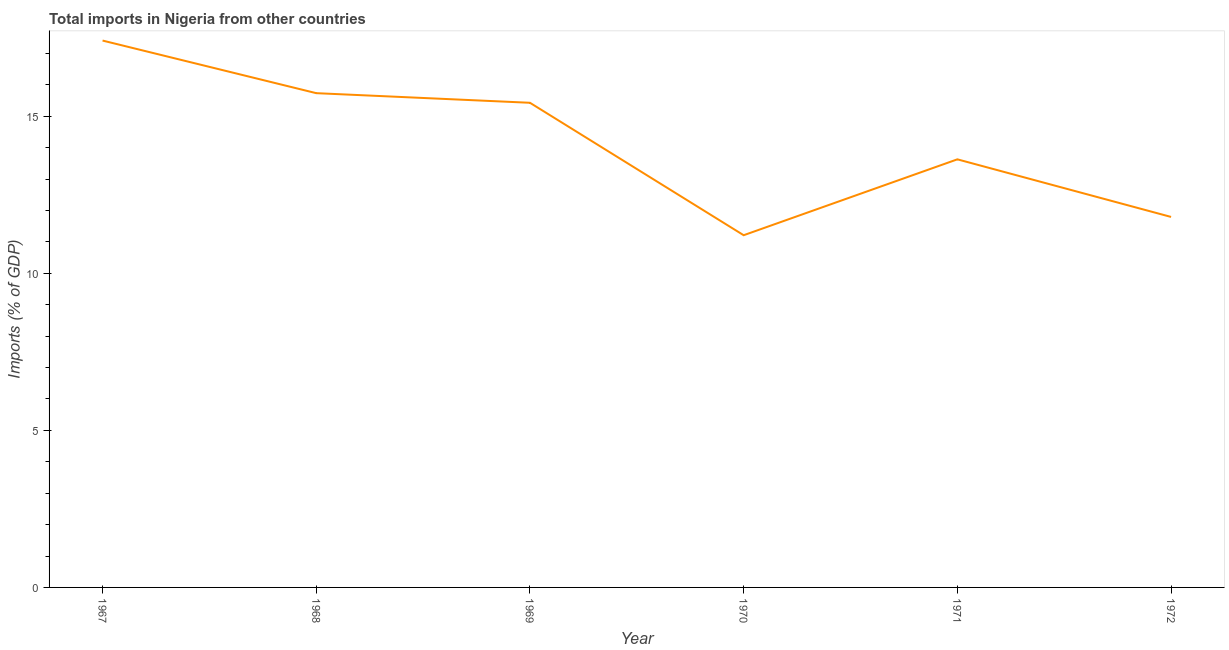What is the total imports in 1971?
Make the answer very short. 13.63. Across all years, what is the maximum total imports?
Offer a terse response. 17.41. Across all years, what is the minimum total imports?
Provide a short and direct response. 11.21. In which year was the total imports maximum?
Offer a very short reply. 1967. In which year was the total imports minimum?
Make the answer very short. 1970. What is the sum of the total imports?
Offer a terse response. 85.22. What is the difference between the total imports in 1969 and 1972?
Offer a very short reply. 3.63. What is the average total imports per year?
Offer a very short reply. 14.2. What is the median total imports?
Ensure brevity in your answer.  14.53. In how many years, is the total imports greater than 4 %?
Ensure brevity in your answer.  6. What is the ratio of the total imports in 1969 to that in 1971?
Provide a short and direct response. 1.13. Is the total imports in 1968 less than that in 1972?
Your response must be concise. No. Is the difference between the total imports in 1970 and 1972 greater than the difference between any two years?
Ensure brevity in your answer.  No. What is the difference between the highest and the second highest total imports?
Offer a very short reply. 1.67. Is the sum of the total imports in 1968 and 1969 greater than the maximum total imports across all years?
Offer a terse response. Yes. What is the difference between the highest and the lowest total imports?
Provide a short and direct response. 6.2. Does the total imports monotonically increase over the years?
Your answer should be compact. No. How many lines are there?
Provide a short and direct response. 1. Does the graph contain any zero values?
Make the answer very short. No. Does the graph contain grids?
Ensure brevity in your answer.  No. What is the title of the graph?
Your response must be concise. Total imports in Nigeria from other countries. What is the label or title of the X-axis?
Make the answer very short. Year. What is the label or title of the Y-axis?
Make the answer very short. Imports (% of GDP). What is the Imports (% of GDP) of 1967?
Your answer should be very brief. 17.41. What is the Imports (% of GDP) of 1968?
Provide a short and direct response. 15.74. What is the Imports (% of GDP) of 1969?
Give a very brief answer. 15.43. What is the Imports (% of GDP) of 1970?
Give a very brief answer. 11.21. What is the Imports (% of GDP) of 1971?
Your answer should be compact. 13.63. What is the Imports (% of GDP) of 1972?
Keep it short and to the point. 11.8. What is the difference between the Imports (% of GDP) in 1967 and 1968?
Make the answer very short. 1.67. What is the difference between the Imports (% of GDP) in 1967 and 1969?
Your response must be concise. 1.98. What is the difference between the Imports (% of GDP) in 1967 and 1970?
Provide a succinct answer. 6.2. What is the difference between the Imports (% of GDP) in 1967 and 1971?
Give a very brief answer. 3.78. What is the difference between the Imports (% of GDP) in 1967 and 1972?
Ensure brevity in your answer.  5.62. What is the difference between the Imports (% of GDP) in 1968 and 1969?
Provide a short and direct response. 0.31. What is the difference between the Imports (% of GDP) in 1968 and 1970?
Make the answer very short. 4.52. What is the difference between the Imports (% of GDP) in 1968 and 1971?
Ensure brevity in your answer.  2.11. What is the difference between the Imports (% of GDP) in 1968 and 1972?
Ensure brevity in your answer.  3.94. What is the difference between the Imports (% of GDP) in 1969 and 1970?
Your response must be concise. 4.22. What is the difference between the Imports (% of GDP) in 1969 and 1971?
Provide a short and direct response. 1.8. What is the difference between the Imports (% of GDP) in 1969 and 1972?
Offer a terse response. 3.63. What is the difference between the Imports (% of GDP) in 1970 and 1971?
Offer a very short reply. -2.42. What is the difference between the Imports (% of GDP) in 1970 and 1972?
Your answer should be compact. -0.58. What is the difference between the Imports (% of GDP) in 1971 and 1972?
Provide a succinct answer. 1.83. What is the ratio of the Imports (% of GDP) in 1967 to that in 1968?
Give a very brief answer. 1.11. What is the ratio of the Imports (% of GDP) in 1967 to that in 1969?
Your response must be concise. 1.13. What is the ratio of the Imports (% of GDP) in 1967 to that in 1970?
Your answer should be compact. 1.55. What is the ratio of the Imports (% of GDP) in 1967 to that in 1971?
Keep it short and to the point. 1.28. What is the ratio of the Imports (% of GDP) in 1967 to that in 1972?
Offer a very short reply. 1.48. What is the ratio of the Imports (% of GDP) in 1968 to that in 1970?
Your answer should be very brief. 1.4. What is the ratio of the Imports (% of GDP) in 1968 to that in 1971?
Make the answer very short. 1.16. What is the ratio of the Imports (% of GDP) in 1968 to that in 1972?
Keep it short and to the point. 1.33. What is the ratio of the Imports (% of GDP) in 1969 to that in 1970?
Give a very brief answer. 1.38. What is the ratio of the Imports (% of GDP) in 1969 to that in 1971?
Provide a short and direct response. 1.13. What is the ratio of the Imports (% of GDP) in 1969 to that in 1972?
Offer a terse response. 1.31. What is the ratio of the Imports (% of GDP) in 1970 to that in 1971?
Keep it short and to the point. 0.82. What is the ratio of the Imports (% of GDP) in 1970 to that in 1972?
Offer a terse response. 0.95. What is the ratio of the Imports (% of GDP) in 1971 to that in 1972?
Offer a terse response. 1.16. 